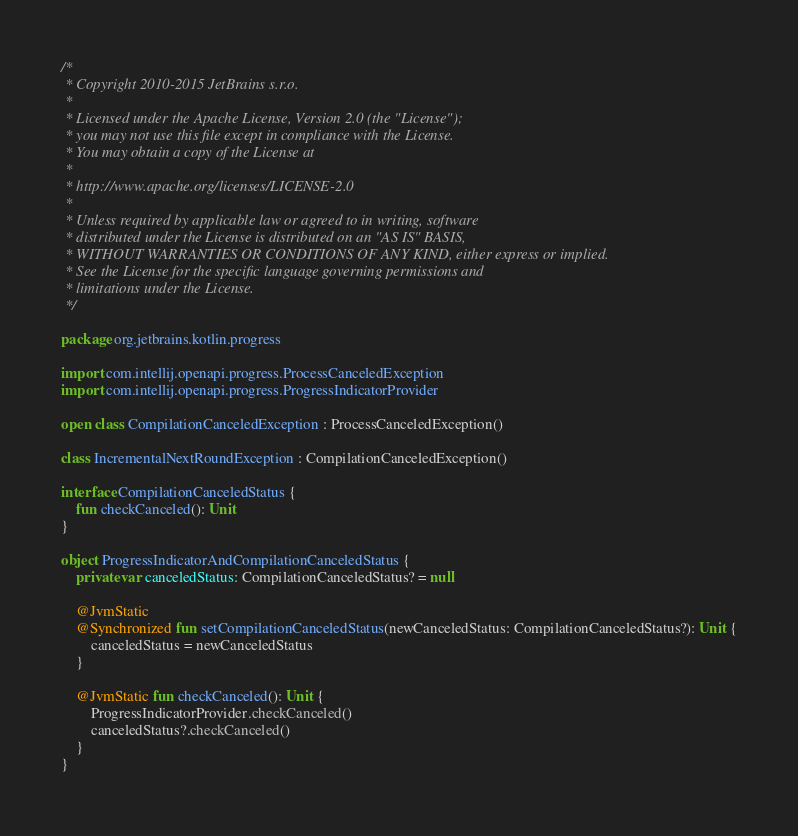<code> <loc_0><loc_0><loc_500><loc_500><_Kotlin_>/*
 * Copyright 2010-2015 JetBrains s.r.o.
 *
 * Licensed under the Apache License, Version 2.0 (the "License");
 * you may not use this file except in compliance with the License.
 * You may obtain a copy of the License at
 *
 * http://www.apache.org/licenses/LICENSE-2.0
 *
 * Unless required by applicable law or agreed to in writing, software
 * distributed under the License is distributed on an "AS IS" BASIS,
 * WITHOUT WARRANTIES OR CONDITIONS OF ANY KIND, either express or implied.
 * See the License for the specific language governing permissions and
 * limitations under the License.
 */

package org.jetbrains.kotlin.progress

import com.intellij.openapi.progress.ProcessCanceledException
import com.intellij.openapi.progress.ProgressIndicatorProvider

open class CompilationCanceledException : ProcessCanceledException()

class IncrementalNextRoundException : CompilationCanceledException()

interface CompilationCanceledStatus {
    fun checkCanceled(): Unit
}

object ProgressIndicatorAndCompilationCanceledStatus {
    private var canceledStatus: CompilationCanceledStatus? = null

    @JvmStatic
    @Synchronized fun setCompilationCanceledStatus(newCanceledStatus: CompilationCanceledStatus?): Unit {
        canceledStatus = newCanceledStatus
    }

    @JvmStatic fun checkCanceled(): Unit {
        ProgressIndicatorProvider.checkCanceled()
        canceledStatus?.checkCanceled()
    }
}</code> 